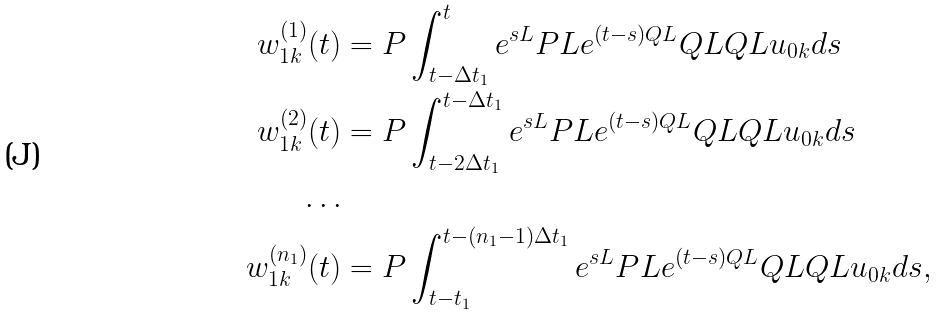Convert formula to latex. <formula><loc_0><loc_0><loc_500><loc_500>w _ { 1 k } ^ { ( 1 ) } ( t ) & = P \int _ { t - \Delta t _ { 1 } } ^ { t } e ^ { s L } P L e ^ { ( t - s ) Q L } Q L Q L u _ { 0 k } d s \\ w _ { 1 k } ^ { ( 2 ) } ( t ) & = P \int _ { t - 2 \Delta t _ { 1 } } ^ { t - \Delta t _ { 1 } } e ^ { s L } P L e ^ { ( t - s ) Q L } Q L Q L u _ { 0 k } d s \\ \dots & \\ w _ { 1 k } ^ { ( n _ { 1 } ) } ( t ) & = P \int _ { t - t _ { 1 } } ^ { t - ( n _ { 1 } - 1 ) \Delta t _ { 1 } } e ^ { s L } P L e ^ { ( t - s ) Q L } Q L Q L u _ { 0 k } d s ,</formula> 